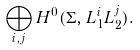<formula> <loc_0><loc_0><loc_500><loc_500>\bigoplus _ { i , j } H ^ { 0 } ( \Sigma , L _ { 1 } ^ { i } L _ { 2 } ^ { j } ) .</formula> 